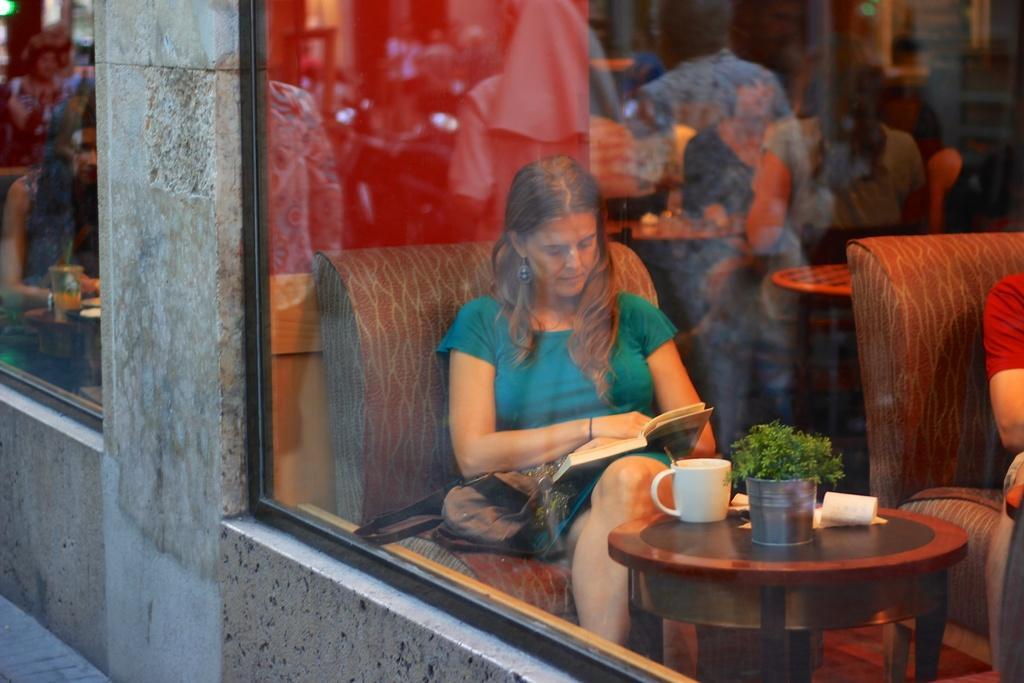In one or two sentences, can you explain what this image depicts? In this image I can see a woman sitting on a chair in front of a table and reading book which is in her hand. On the table I can see a cup and other objects on it. I can also see a glass mirror. 